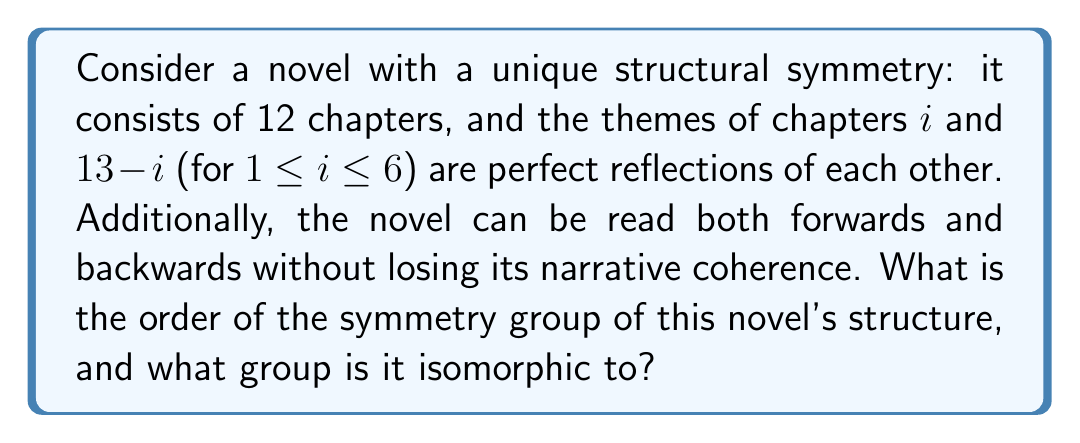Can you solve this math problem? To analyze the symmetry group of this novel's structure, we need to consider the permutations that preserve its symmetry:

1. Identity permutation: Leaves the structure unchanged.

2. Reflection: Swaps chapter $i$ with chapter $13-i$ for all $i$.

3. Rotation: The novel can be read backwards, which is equivalent to a 180° rotation of the chapter order.

These operations form a group under composition. Let's call the identity $e$, the reflection $r$, and the rotation $s$.

The group table would be:

$$
\begin{array}{c|ccc}
  & e & r & s \\
\hline
e & e & r & s \\
r & r & e & s \\
s & s & s & e
\end{array}
$$

We can verify that this group satisfies the axioms:

- Closure: The composition of any two elements is in the group.
- Associativity: Matrix multiplication is associative.
- Identity: $e$ is the identity element.
- Inverse: Each element is its own inverse.

The order of this group is 4.

This group structure is isomorphic to the Klein four-group, also known as $V_4$ or $\mathbb{Z}_2 \times \mathbb{Z}_2$. It's an abelian group of order 4, where every non-identity element has order 2.

In terms of literary analysis, this symmetry group reflects the novel's perfect balance and reversibility, elements that a scholar of literature might find particularly intriguing in analyzing the work's structure and its impact on narrative and thematic development.
Answer: The order of the symmetry group is 4, and it is isomorphic to the Klein four-group ($V_4$ or $\mathbb{Z}_2 \times \mathbb{Z}_2$). 